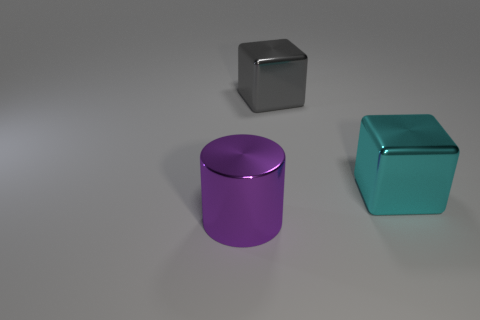Is there another cylinder of the same color as the big cylinder?
Keep it short and to the point. No. There is a cyan metal object; what shape is it?
Make the answer very short. Cube. What color is the large metallic thing that is left of the large metal cube that is behind the big cyan object?
Provide a short and direct response. Purple. What size is the shiny object on the right side of the big gray shiny block?
Offer a terse response. Large. Are there any other things made of the same material as the large purple object?
Provide a short and direct response. Yes. What number of big purple shiny things have the same shape as the gray metal thing?
Offer a terse response. 0. What shape is the big object that is in front of the big metal block that is to the right of the thing that is behind the large cyan object?
Your answer should be very brief. Cylinder. What is the material of the large object that is both left of the big cyan cube and on the right side of the large purple cylinder?
Your answer should be compact. Metal. There is a thing that is in front of the cyan shiny block; is its size the same as the cyan object?
Your response must be concise. Yes. Is there any other thing that has the same size as the gray cube?
Keep it short and to the point. Yes. 